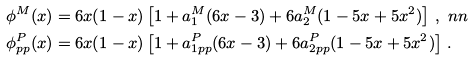Convert formula to latex. <formula><loc_0><loc_0><loc_500><loc_500>\phi ^ { M } ( x ) & = 6 x ( 1 - x ) \left [ 1 + a _ { 1 } ^ { M } ( 6 x - 3 ) + 6 a _ { 2 } ^ { M } ( 1 - 5 x + 5 x ^ { 2 } ) \right ] \, , \ n n \\ \phi _ { p p } ^ { P } ( x ) & = 6 x ( 1 - x ) \left [ 1 + a _ { 1 p p } ^ { P } ( 6 x - 3 ) + 6 a _ { 2 p p } ^ { P } ( 1 - 5 x + 5 x ^ { 2 } ) \right ] \, .</formula> 